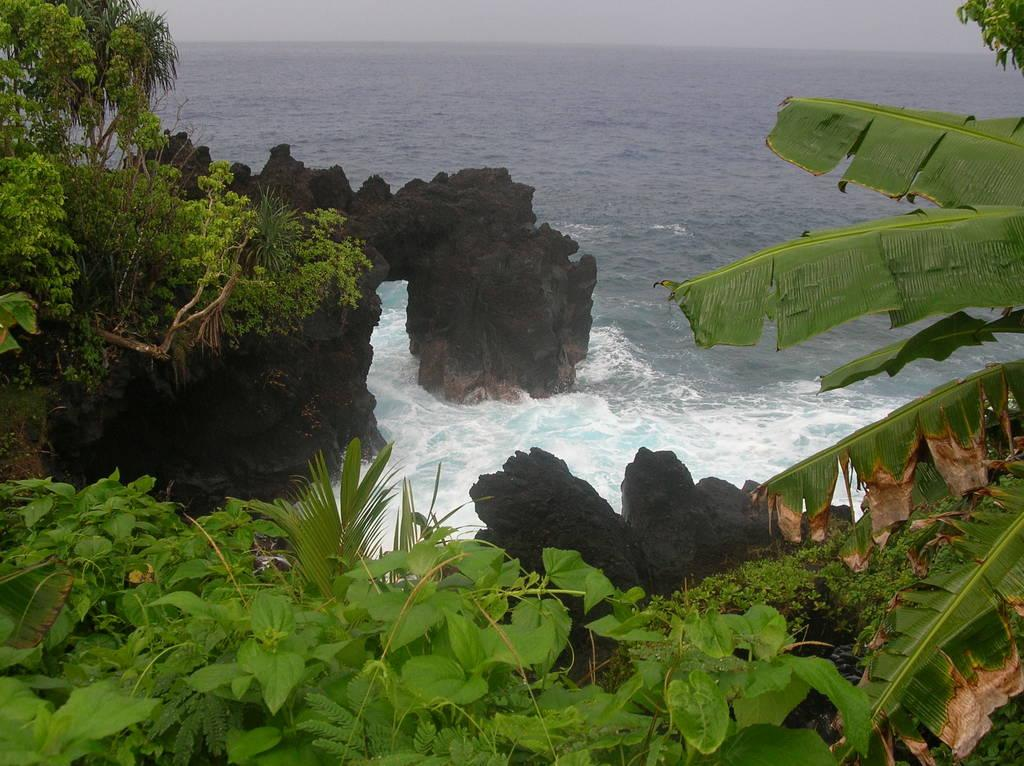What type of natural body of water is present in the image? There is an ocean in the image. What structures can be seen in the image? There are racks visible in the image. What celestial bodies are present in the image? Planets are visible in the image. What type of mask is being used to protect the planets in the image? There is no mask present in the image, and the planets are not in need of protection. 